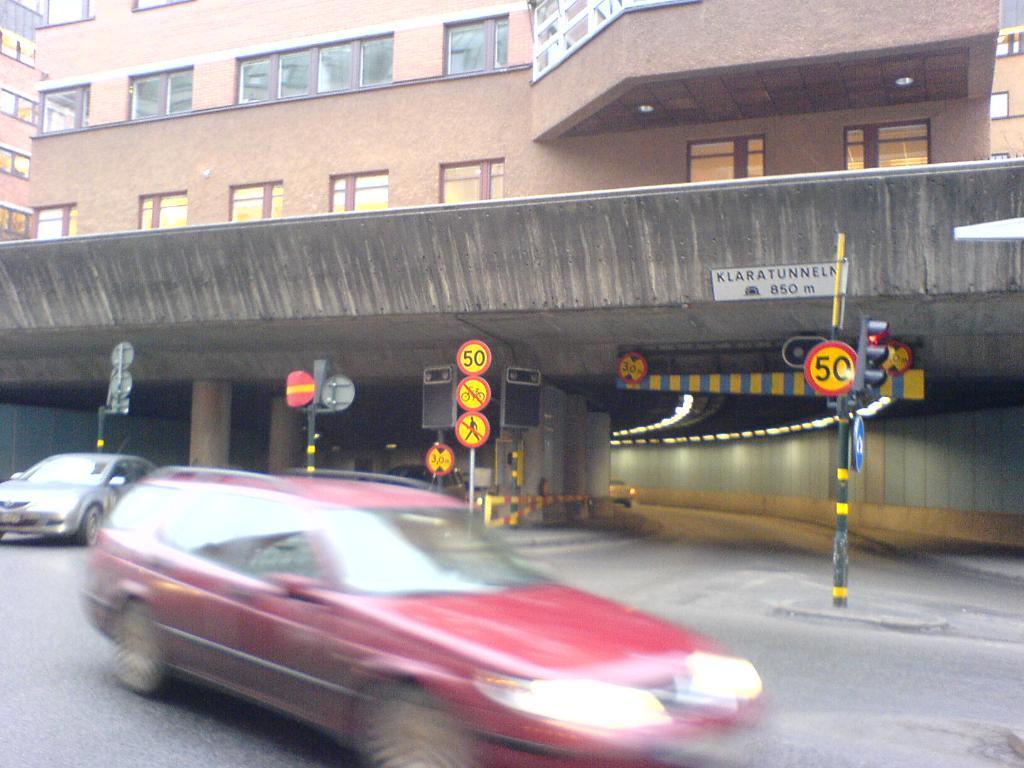What is the speed limit on the sign?
Your answer should be compact. 50. How many meters is posted on the white sign?
Make the answer very short. 850. 